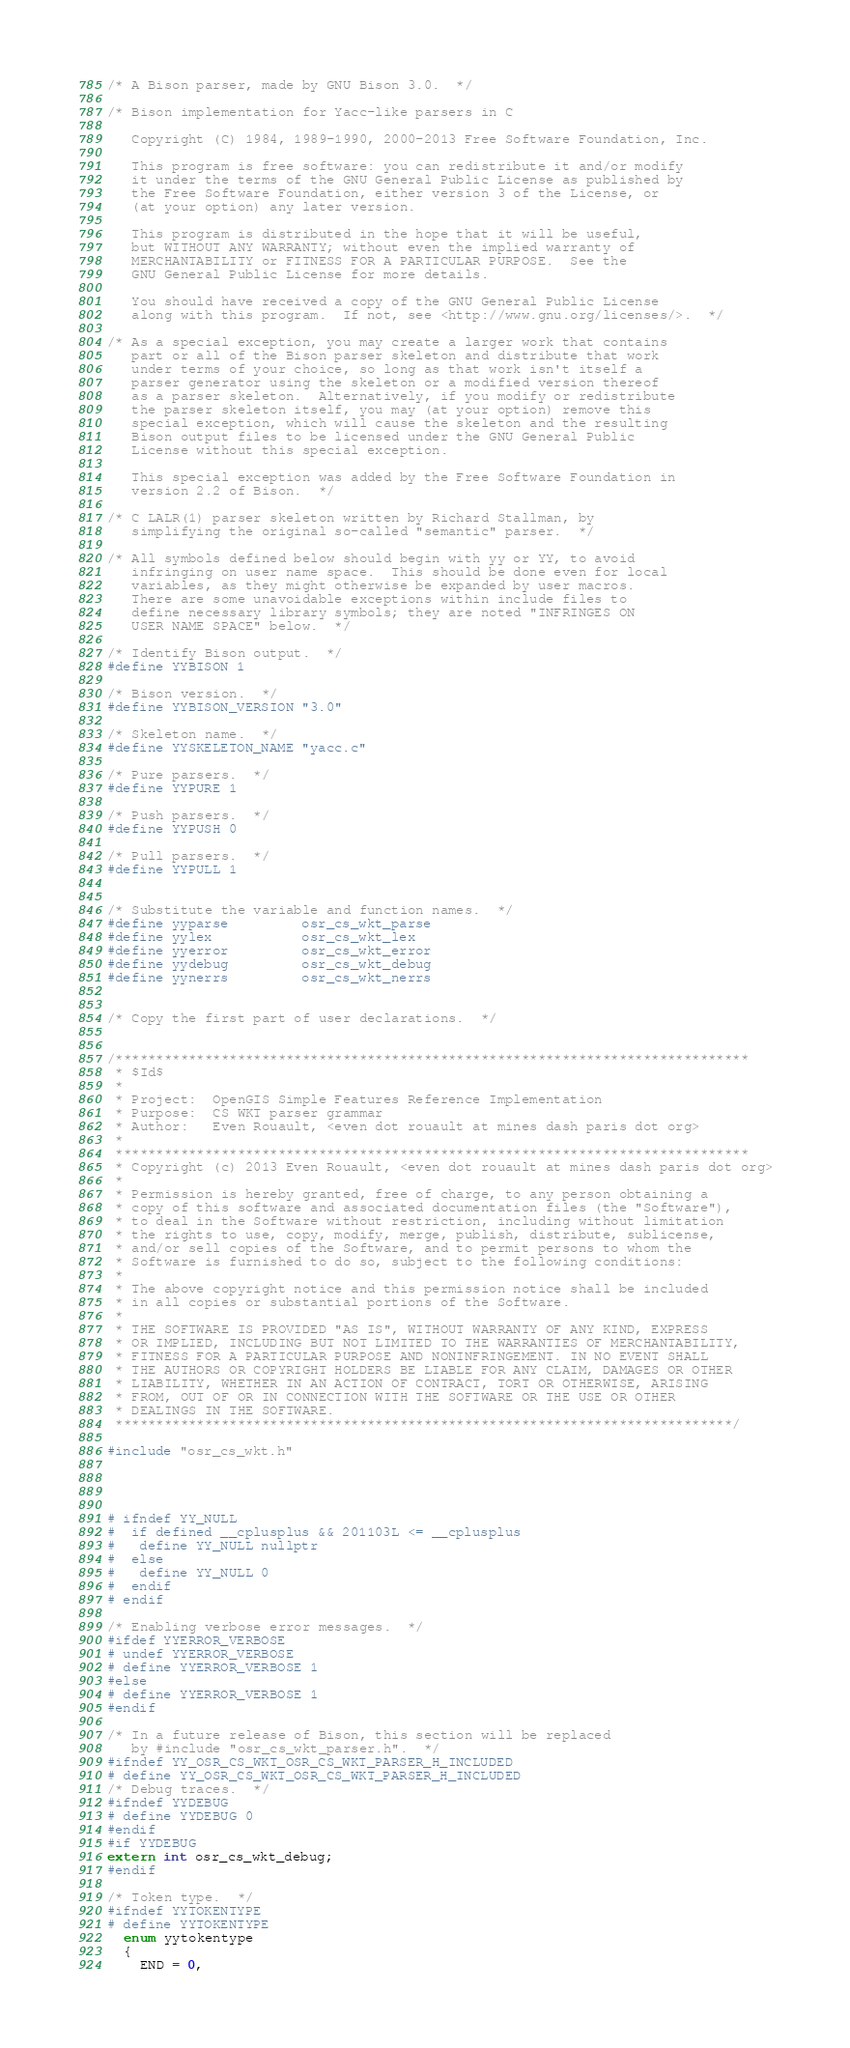<code> <loc_0><loc_0><loc_500><loc_500><_C_>/* A Bison parser, made by GNU Bison 3.0.  */

/* Bison implementation for Yacc-like parsers in C

   Copyright (C) 1984, 1989-1990, 2000-2013 Free Software Foundation, Inc.

   This program is free software: you can redistribute it and/or modify
   it under the terms of the GNU General Public License as published by
   the Free Software Foundation, either version 3 of the License, or
   (at your option) any later version.

   This program is distributed in the hope that it will be useful,
   but WITHOUT ANY WARRANTY; without even the implied warranty of
   MERCHANTABILITY or FITNESS FOR A PARTICULAR PURPOSE.  See the
   GNU General Public License for more details.

   You should have received a copy of the GNU General Public License
   along with this program.  If not, see <http://www.gnu.org/licenses/>.  */

/* As a special exception, you may create a larger work that contains
   part or all of the Bison parser skeleton and distribute that work
   under terms of your choice, so long as that work isn't itself a
   parser generator using the skeleton or a modified version thereof
   as a parser skeleton.  Alternatively, if you modify or redistribute
   the parser skeleton itself, you may (at your option) remove this
   special exception, which will cause the skeleton and the resulting
   Bison output files to be licensed under the GNU General Public
   License without this special exception.

   This special exception was added by the Free Software Foundation in
   version 2.2 of Bison.  */

/* C LALR(1) parser skeleton written by Richard Stallman, by
   simplifying the original so-called "semantic" parser.  */

/* All symbols defined below should begin with yy or YY, to avoid
   infringing on user name space.  This should be done even for local
   variables, as they might otherwise be expanded by user macros.
   There are some unavoidable exceptions within include files to
   define necessary library symbols; they are noted "INFRINGES ON
   USER NAME SPACE" below.  */

/* Identify Bison output.  */
#define YYBISON 1

/* Bison version.  */
#define YYBISON_VERSION "3.0"

/* Skeleton name.  */
#define YYSKELETON_NAME "yacc.c"

/* Pure parsers.  */
#define YYPURE 1

/* Push parsers.  */
#define YYPUSH 0

/* Pull parsers.  */
#define YYPULL 1


/* Substitute the variable and function names.  */
#define yyparse         osr_cs_wkt_parse
#define yylex           osr_cs_wkt_lex
#define yyerror         osr_cs_wkt_error
#define yydebug         osr_cs_wkt_debug
#define yynerrs         osr_cs_wkt_nerrs


/* Copy the first part of user declarations.  */


/******************************************************************************
 * $Id$
 *
 * Project:  OpenGIS Simple Features Reference Implementation
 * Purpose:  CS WKT parser grammar
 * Author:   Even Rouault, <even dot rouault at mines dash paris dot org>
 *
 ******************************************************************************
 * Copyright (c) 2013 Even Rouault, <even dot rouault at mines dash paris dot org>
 *
 * Permission is hereby granted, free of charge, to any person obtaining a
 * copy of this software and associated documentation files (the "Software"),
 * to deal in the Software without restriction, including without limitation
 * the rights to use, copy, modify, merge, publish, distribute, sublicense,
 * and/or sell copies of the Software, and to permit persons to whom the
 * Software is furnished to do so, subject to the following conditions:
 *
 * The above copyright notice and this permission notice shall be included
 * in all copies or substantial portions of the Software.
 *
 * THE SOFTWARE IS PROVIDED "AS IS", WITHOUT WARRANTY OF ANY KIND, EXPRESS
 * OR IMPLIED, INCLUDING BUT NOT LIMITED TO THE WARRANTIES OF MERCHANTABILITY,
 * FITNESS FOR A PARTICULAR PURPOSE AND NONINFRINGEMENT. IN NO EVENT SHALL
 * THE AUTHORS OR COPYRIGHT HOLDERS BE LIABLE FOR ANY CLAIM, DAMAGES OR OTHER
 * LIABILITY, WHETHER IN AN ACTION OF CONTRACT, TORT OR OTHERWISE, ARISING
 * FROM, OUT OF OR IN CONNECTION WITH THE SOFTWARE OR THE USE OR OTHER
 * DEALINGS IN THE SOFTWARE.
 ****************************************************************************/

#include "osr_cs_wkt.h"




# ifndef YY_NULL
#  if defined __cplusplus && 201103L <= __cplusplus
#   define YY_NULL nullptr
#  else
#   define YY_NULL 0
#  endif
# endif

/* Enabling verbose error messages.  */
#ifdef YYERROR_VERBOSE
# undef YYERROR_VERBOSE
# define YYERROR_VERBOSE 1
#else
# define YYERROR_VERBOSE 1
#endif

/* In a future release of Bison, this section will be replaced
   by #include "osr_cs_wkt_parser.h".  */
#ifndef YY_OSR_CS_WKT_OSR_CS_WKT_PARSER_H_INCLUDED
# define YY_OSR_CS_WKT_OSR_CS_WKT_PARSER_H_INCLUDED
/* Debug traces.  */
#ifndef YYDEBUG
# define YYDEBUG 0
#endif
#if YYDEBUG
extern int osr_cs_wkt_debug;
#endif

/* Token type.  */
#ifndef YYTOKENTYPE
# define YYTOKENTYPE
  enum yytokentype
  {
    END = 0,</code> 